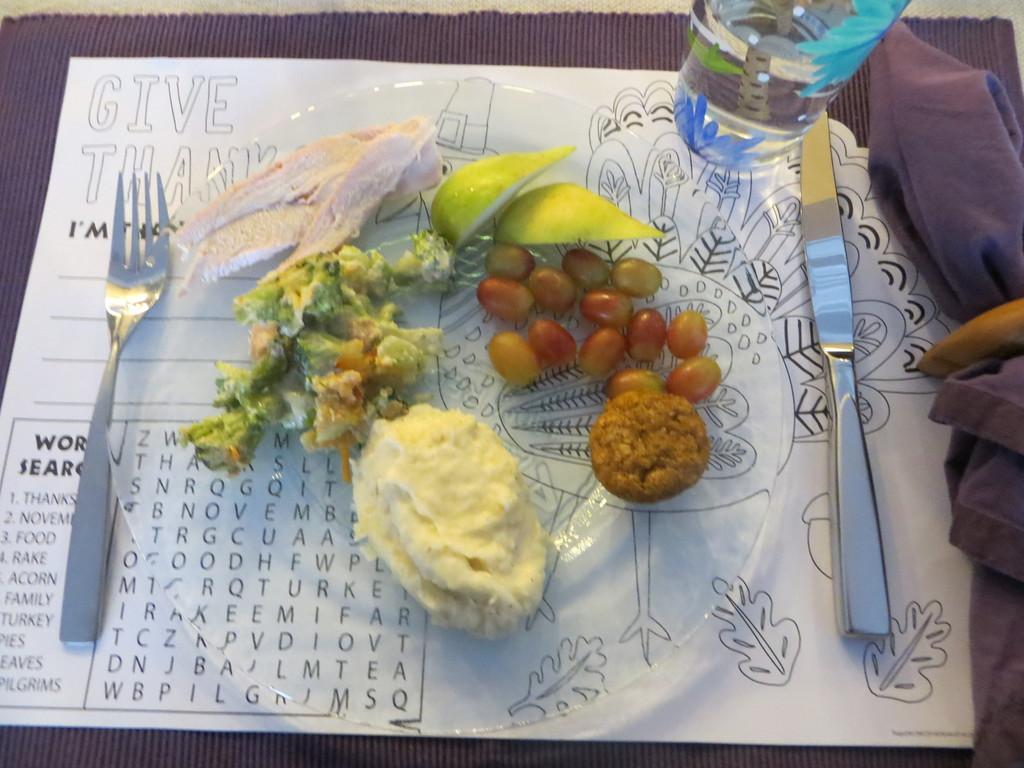How would you summarize this image in a sentence or two? In this image we can see a white color paper. In the paper, we can see the food. We have fork on the left side and the knife on the right side. Under the paper, we have gray color cloth and also right side we have gray cloth. 